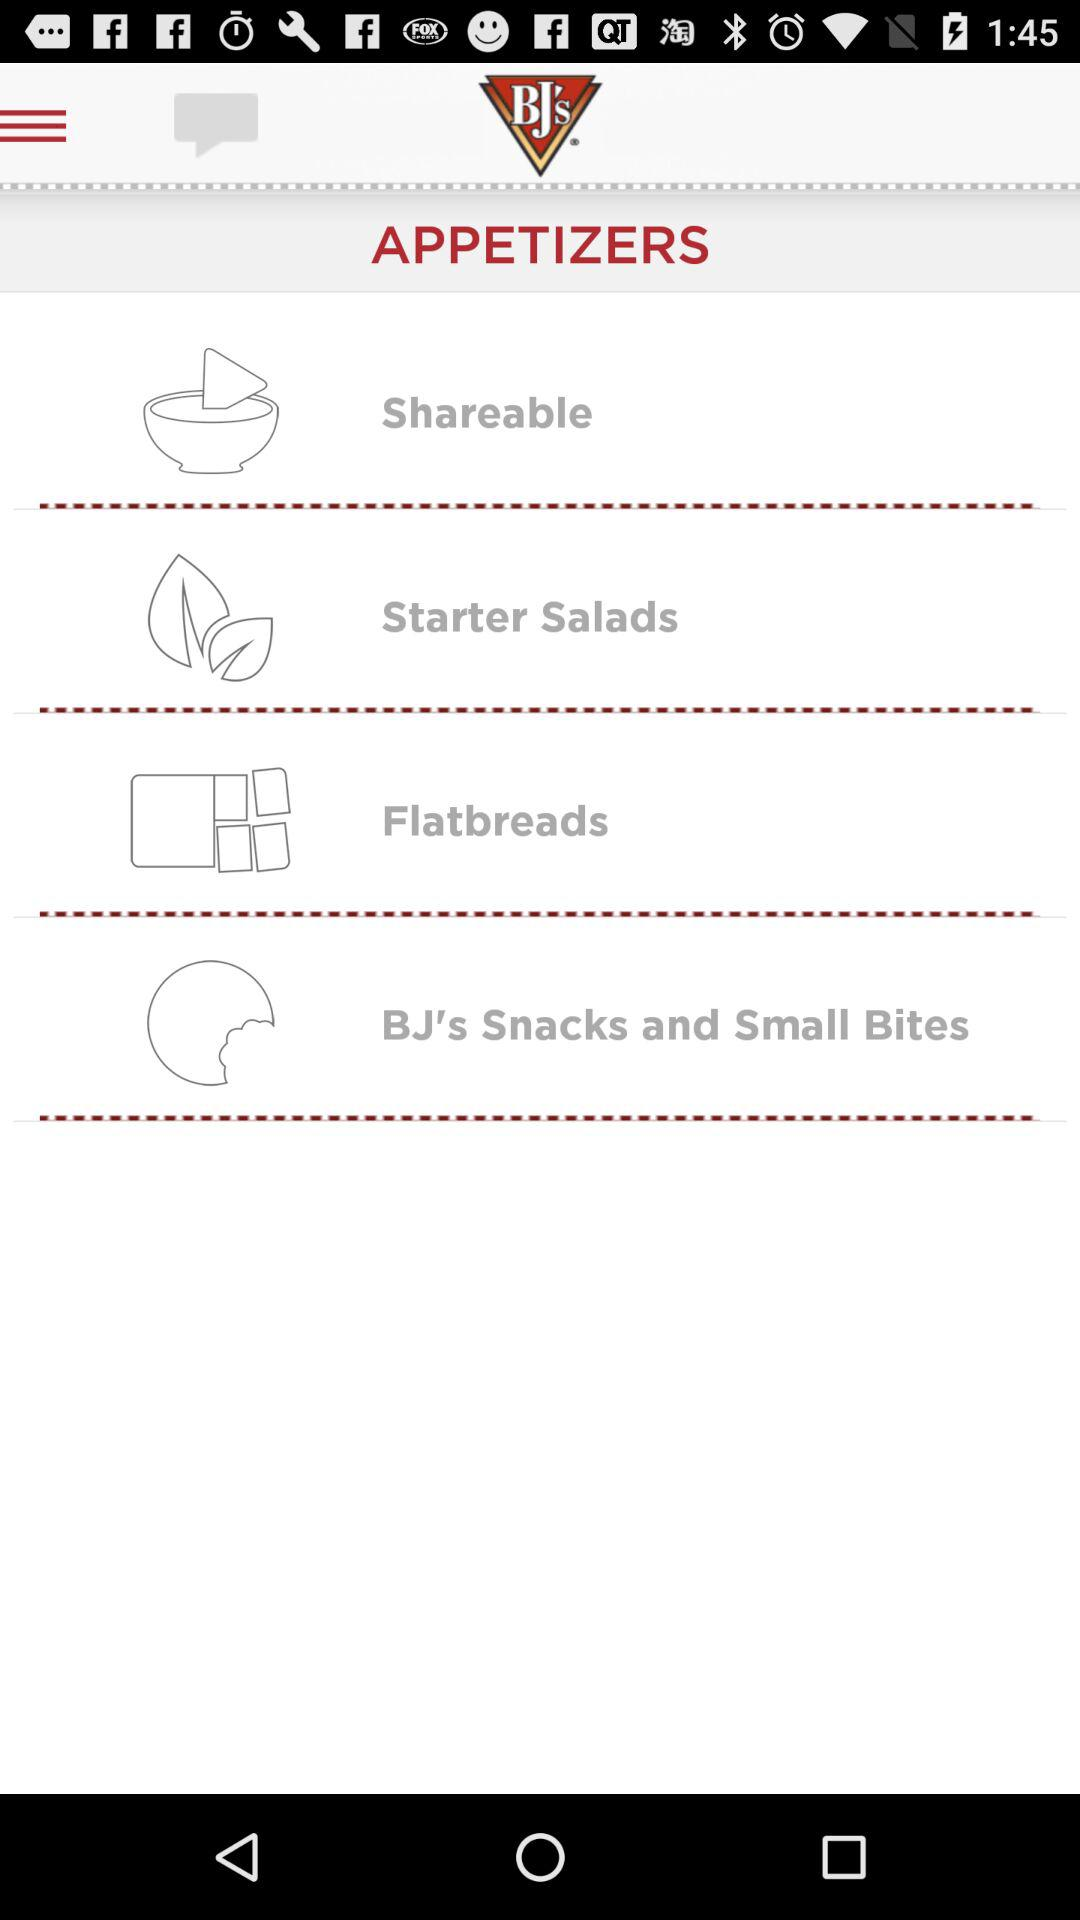What is the name of the application? The name of the application is "BJ'S". 